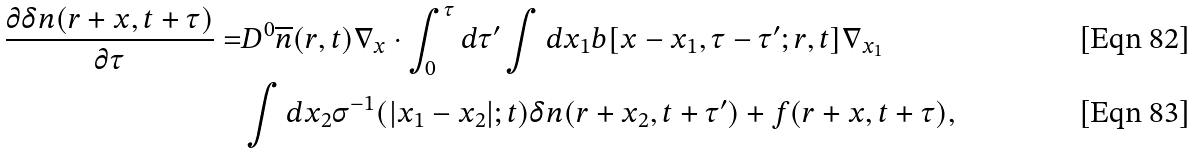Convert formula to latex. <formula><loc_0><loc_0><loc_500><loc_500>\frac { \partial \delta n ( r + x , t + \tau ) } { \partial \tau } = & D ^ { 0 } \overline { n } ( r , t ) { \nabla } _ { x } \cdot \int _ { 0 } ^ { \tau } d \tau ^ { \prime } \int d x _ { 1 } b [ x - x _ { 1 } , \tau - \tau ^ { \prime } ; r , t ] \nabla _ { x _ { 1 } } \\ & \int d x _ { 2 } \sigma ^ { - 1 } ( | x _ { 1 } - x _ { 2 } | ; t ) \delta n ( r + x _ { 2 } , t + \tau ^ { \prime } ) + f ( r + x , t + \tau ) ,</formula> 